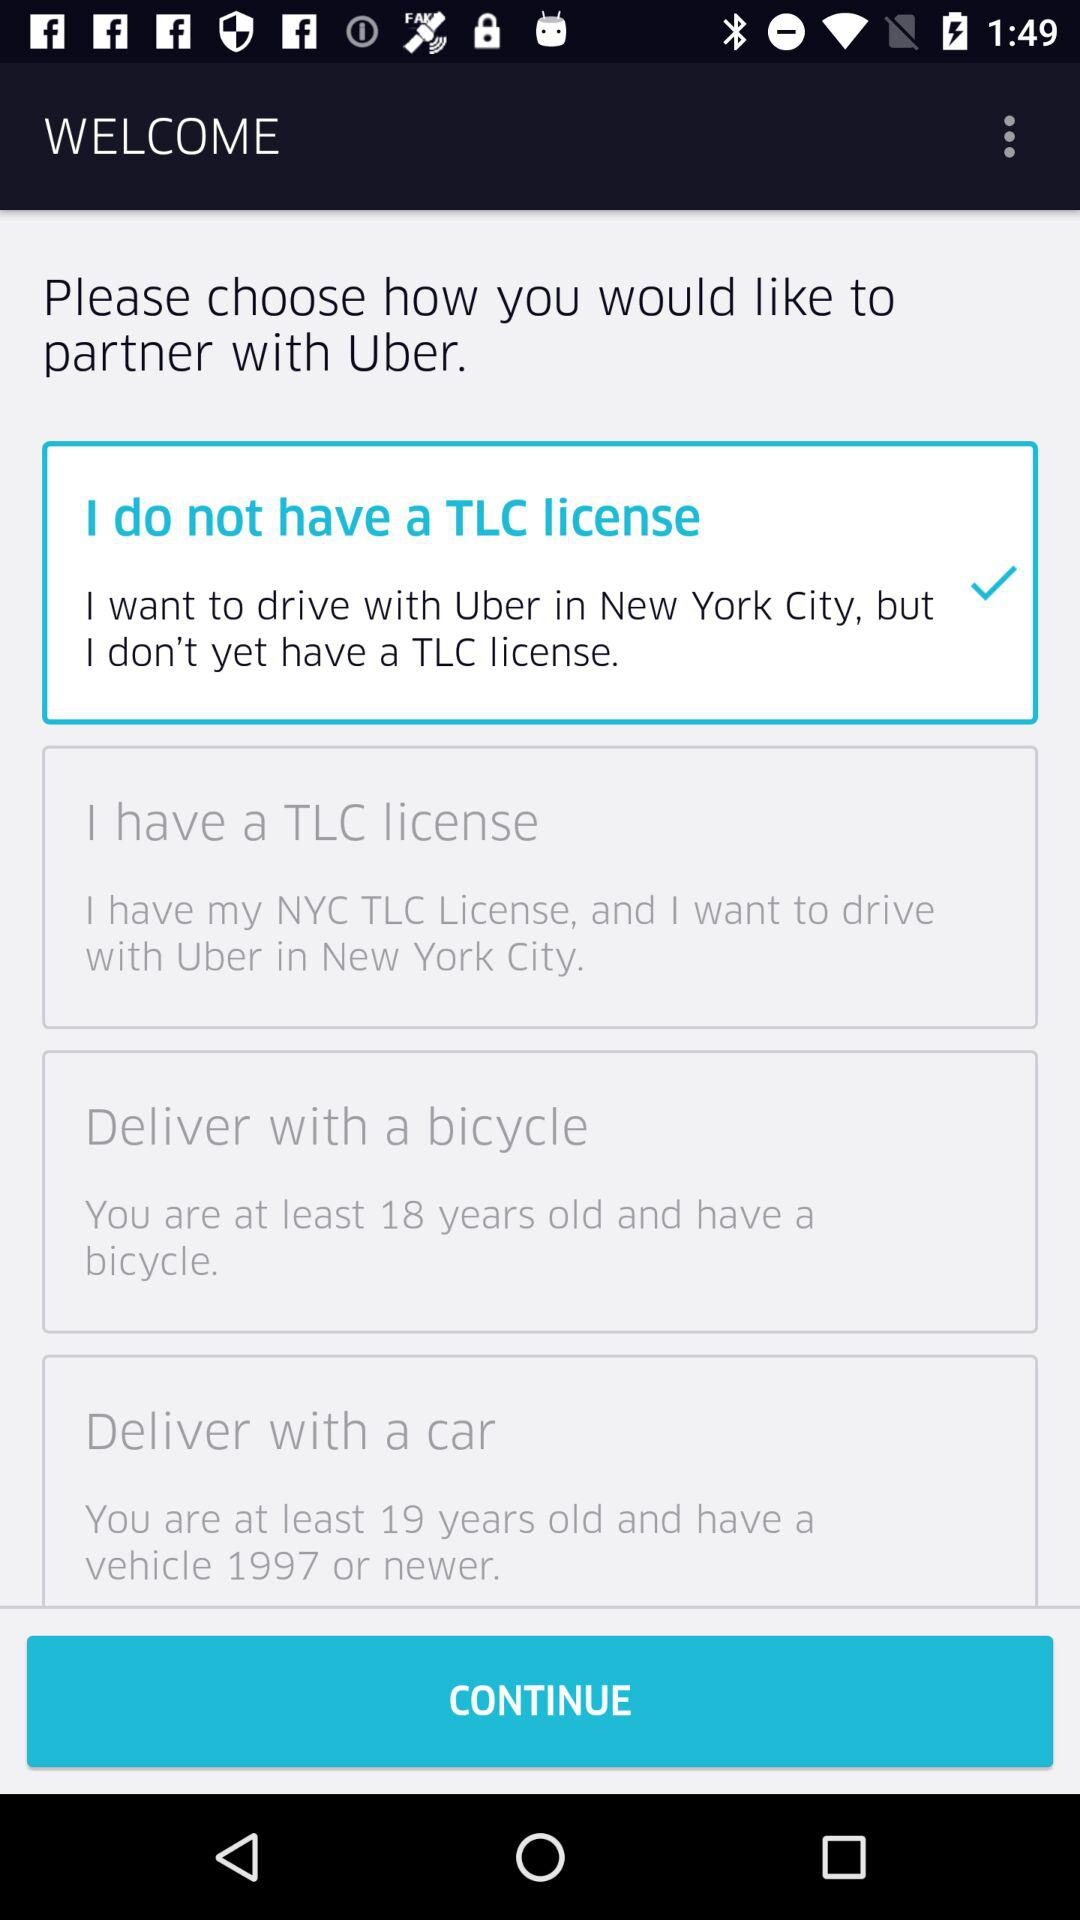What is the least age to have a vehicle in 1997?
When the provided information is insufficient, respond with <no answer>. <no answer> 